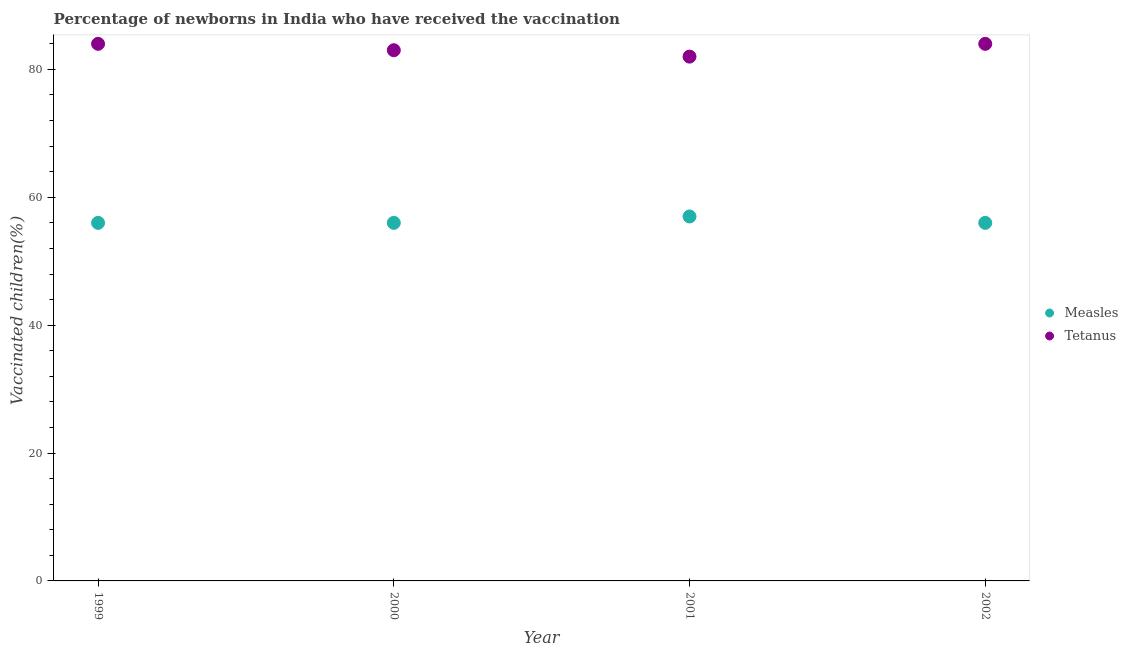How many different coloured dotlines are there?
Give a very brief answer. 2. What is the percentage of newborns who received vaccination for measles in 2001?
Provide a short and direct response. 57. Across all years, what is the maximum percentage of newborns who received vaccination for tetanus?
Provide a succinct answer. 84. Across all years, what is the minimum percentage of newborns who received vaccination for measles?
Provide a short and direct response. 56. In which year was the percentage of newborns who received vaccination for measles maximum?
Your answer should be very brief. 2001. In which year was the percentage of newborns who received vaccination for tetanus minimum?
Offer a very short reply. 2001. What is the total percentage of newborns who received vaccination for tetanus in the graph?
Your answer should be very brief. 333. What is the difference between the percentage of newborns who received vaccination for measles in 2000 and that in 2001?
Your answer should be compact. -1. What is the difference between the percentage of newborns who received vaccination for tetanus in 2002 and the percentage of newborns who received vaccination for measles in 2000?
Your answer should be very brief. 28. What is the average percentage of newborns who received vaccination for measles per year?
Your response must be concise. 56.25. In the year 2000, what is the difference between the percentage of newborns who received vaccination for measles and percentage of newborns who received vaccination for tetanus?
Give a very brief answer. -27. In how many years, is the percentage of newborns who received vaccination for measles greater than 56 %?
Offer a very short reply. 1. What is the ratio of the percentage of newborns who received vaccination for measles in 2001 to that in 2002?
Your answer should be compact. 1.02. Is the percentage of newborns who received vaccination for measles in 2000 less than that in 2002?
Make the answer very short. No. What is the difference between the highest and the second highest percentage of newborns who received vaccination for measles?
Your answer should be compact. 1. What is the difference between the highest and the lowest percentage of newborns who received vaccination for tetanus?
Your response must be concise. 2. Does the percentage of newborns who received vaccination for measles monotonically increase over the years?
Offer a very short reply. No. Is the percentage of newborns who received vaccination for measles strictly greater than the percentage of newborns who received vaccination for tetanus over the years?
Your answer should be compact. No. How many dotlines are there?
Make the answer very short. 2. Does the graph contain any zero values?
Your response must be concise. No. Where does the legend appear in the graph?
Offer a very short reply. Center right. What is the title of the graph?
Provide a succinct answer. Percentage of newborns in India who have received the vaccination. Does "Non-solid fuel" appear as one of the legend labels in the graph?
Offer a terse response. No. What is the label or title of the X-axis?
Ensure brevity in your answer.  Year. What is the label or title of the Y-axis?
Offer a terse response. Vaccinated children(%)
. What is the Vaccinated children(%)
 of Measles in 2002?
Offer a terse response. 56. Across all years, what is the minimum Vaccinated children(%)
 of Measles?
Make the answer very short. 56. Across all years, what is the minimum Vaccinated children(%)
 of Tetanus?
Provide a succinct answer. 82. What is the total Vaccinated children(%)
 of Measles in the graph?
Keep it short and to the point. 225. What is the total Vaccinated children(%)
 in Tetanus in the graph?
Offer a terse response. 333. What is the difference between the Vaccinated children(%)
 of Measles in 1999 and that in 2000?
Your response must be concise. 0. What is the difference between the Vaccinated children(%)
 in Tetanus in 1999 and that in 2000?
Keep it short and to the point. 1. What is the difference between the Vaccinated children(%)
 in Tetanus in 2000 and that in 2001?
Give a very brief answer. 1. What is the difference between the Vaccinated children(%)
 in Measles in 2000 and that in 2002?
Your answer should be compact. 0. What is the difference between the Vaccinated children(%)
 of Tetanus in 2000 and that in 2002?
Make the answer very short. -1. What is the difference between the Vaccinated children(%)
 in Measles in 2001 and that in 2002?
Ensure brevity in your answer.  1. What is the difference between the Vaccinated children(%)
 of Tetanus in 2001 and that in 2002?
Offer a very short reply. -2. What is the difference between the Vaccinated children(%)
 in Measles in 1999 and the Vaccinated children(%)
 in Tetanus in 2000?
Offer a very short reply. -27. What is the difference between the Vaccinated children(%)
 of Measles in 1999 and the Vaccinated children(%)
 of Tetanus in 2001?
Provide a short and direct response. -26. What is the difference between the Vaccinated children(%)
 of Measles in 2000 and the Vaccinated children(%)
 of Tetanus in 2001?
Offer a terse response. -26. What is the average Vaccinated children(%)
 in Measles per year?
Offer a very short reply. 56.25. What is the average Vaccinated children(%)
 of Tetanus per year?
Ensure brevity in your answer.  83.25. In the year 2002, what is the difference between the Vaccinated children(%)
 in Measles and Vaccinated children(%)
 in Tetanus?
Give a very brief answer. -28. What is the ratio of the Vaccinated children(%)
 in Measles in 1999 to that in 2001?
Offer a terse response. 0.98. What is the ratio of the Vaccinated children(%)
 in Tetanus in 1999 to that in 2001?
Keep it short and to the point. 1.02. What is the ratio of the Vaccinated children(%)
 in Measles in 1999 to that in 2002?
Your answer should be compact. 1. What is the ratio of the Vaccinated children(%)
 of Tetanus in 1999 to that in 2002?
Give a very brief answer. 1. What is the ratio of the Vaccinated children(%)
 in Measles in 2000 to that in 2001?
Provide a succinct answer. 0.98. What is the ratio of the Vaccinated children(%)
 of Tetanus in 2000 to that in 2001?
Keep it short and to the point. 1.01. What is the ratio of the Vaccinated children(%)
 of Measles in 2000 to that in 2002?
Offer a very short reply. 1. What is the ratio of the Vaccinated children(%)
 of Measles in 2001 to that in 2002?
Ensure brevity in your answer.  1.02. What is the ratio of the Vaccinated children(%)
 of Tetanus in 2001 to that in 2002?
Provide a short and direct response. 0.98. What is the difference between the highest and the lowest Vaccinated children(%)
 in Tetanus?
Provide a short and direct response. 2. 